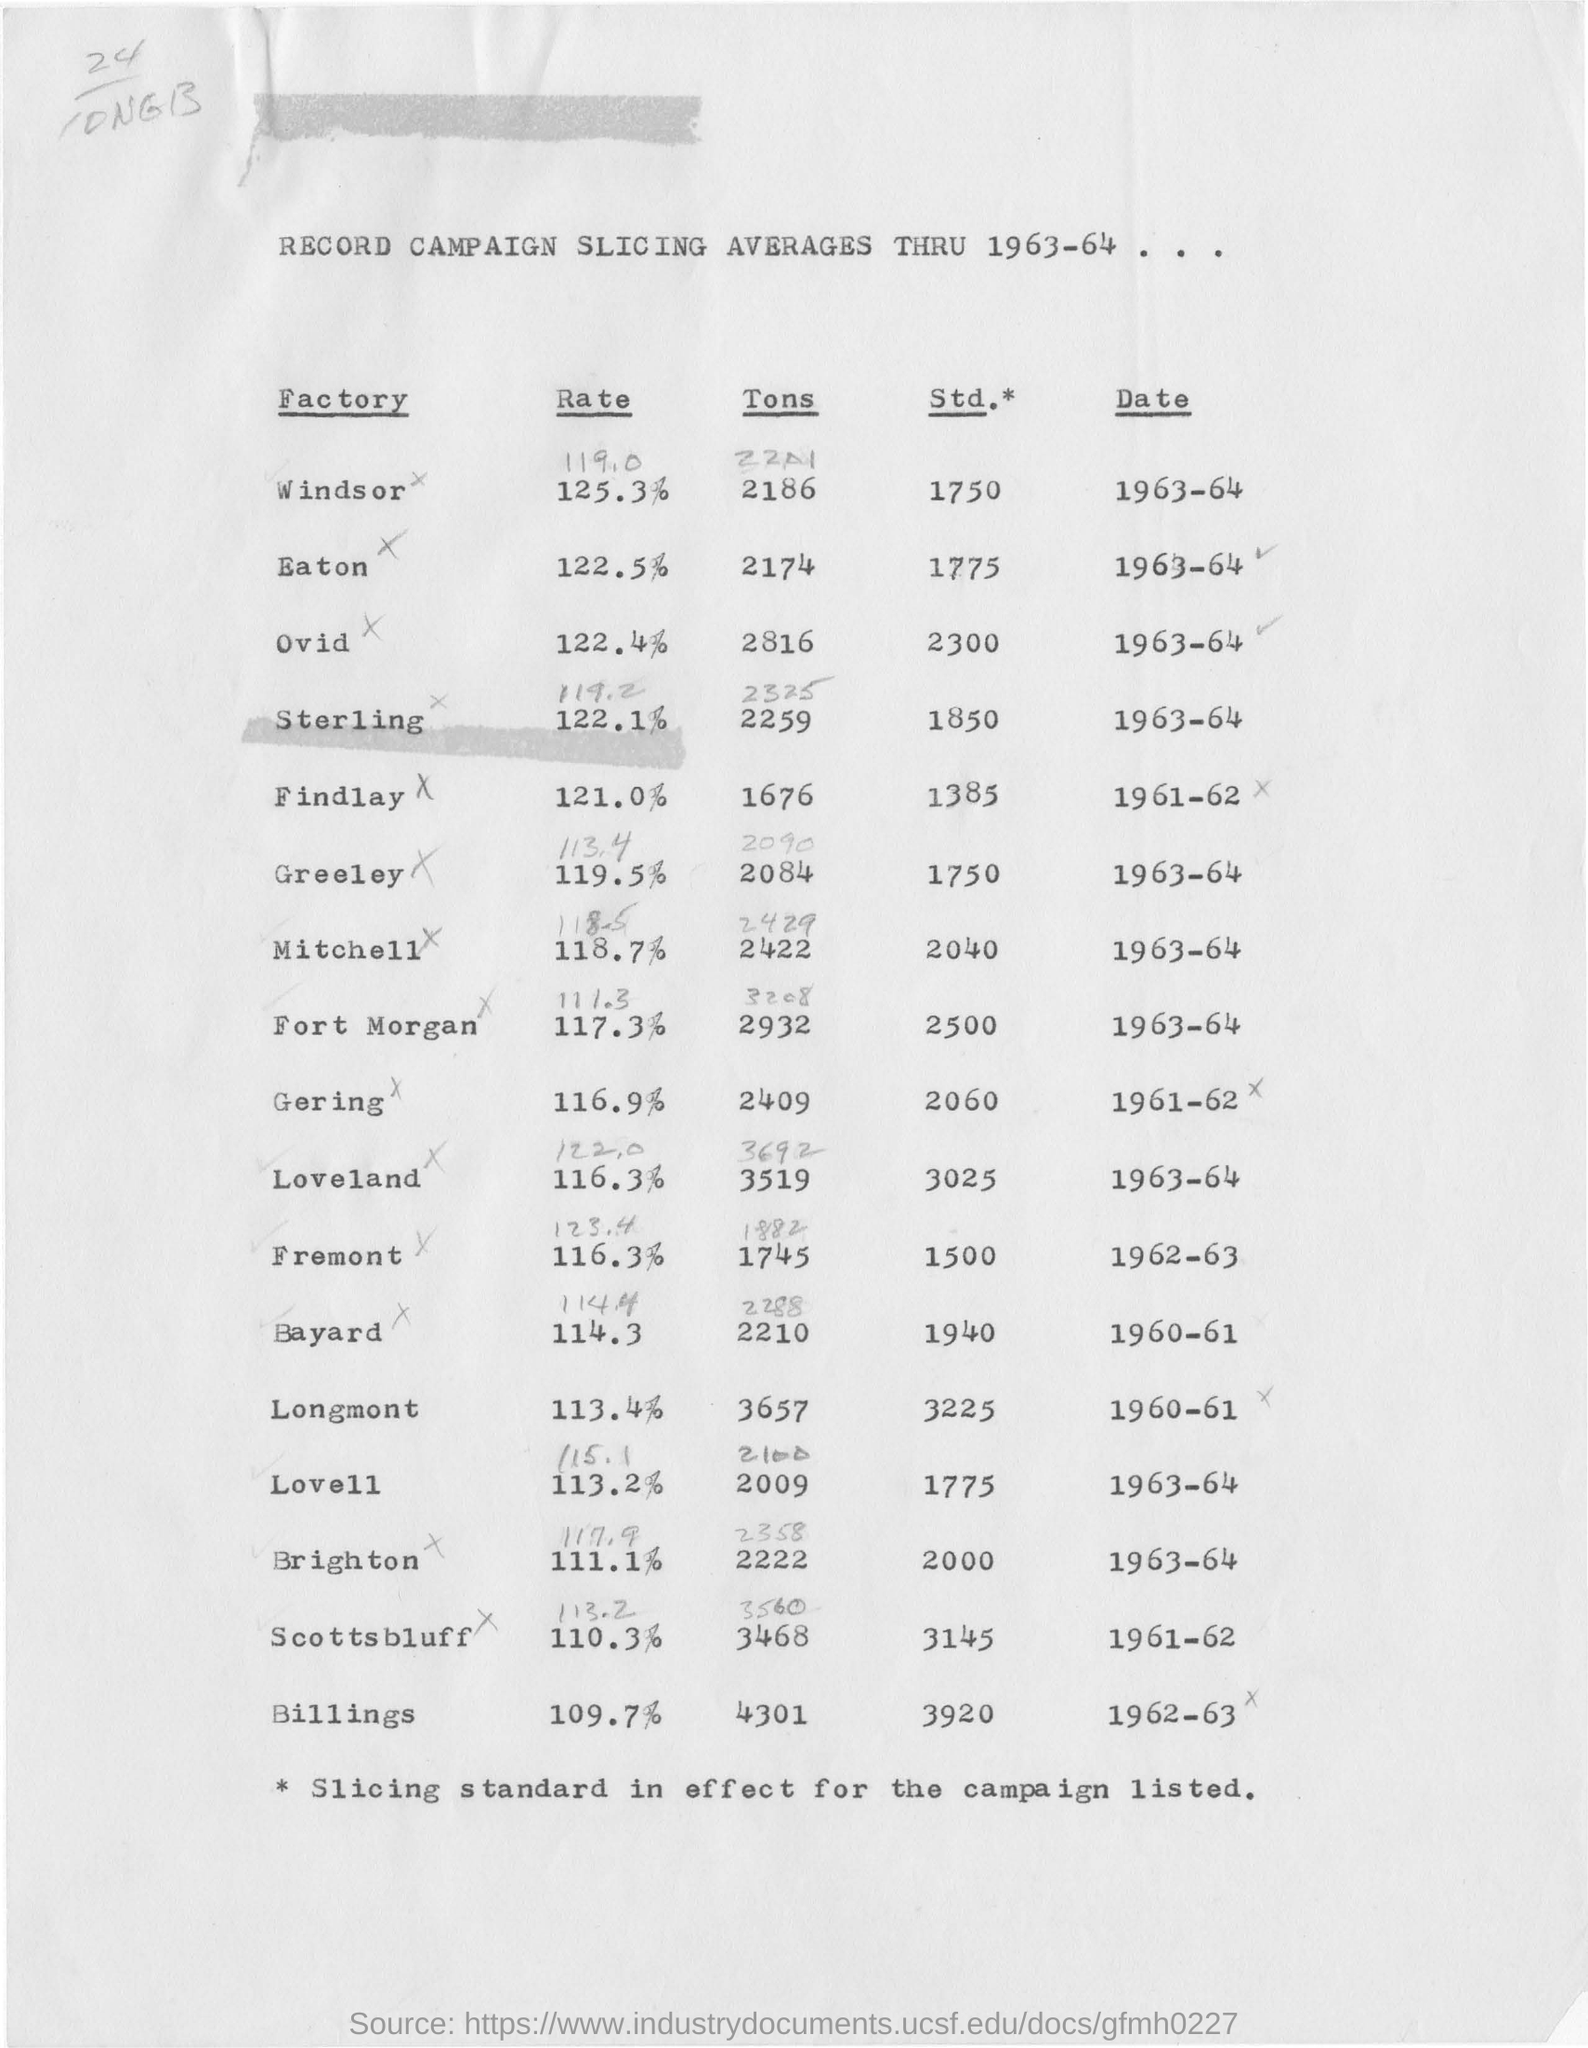What is the head line of the document?
Offer a very short reply. RECORD CAMPAIGN SLICING AVERAGES THRU 1963-64... 